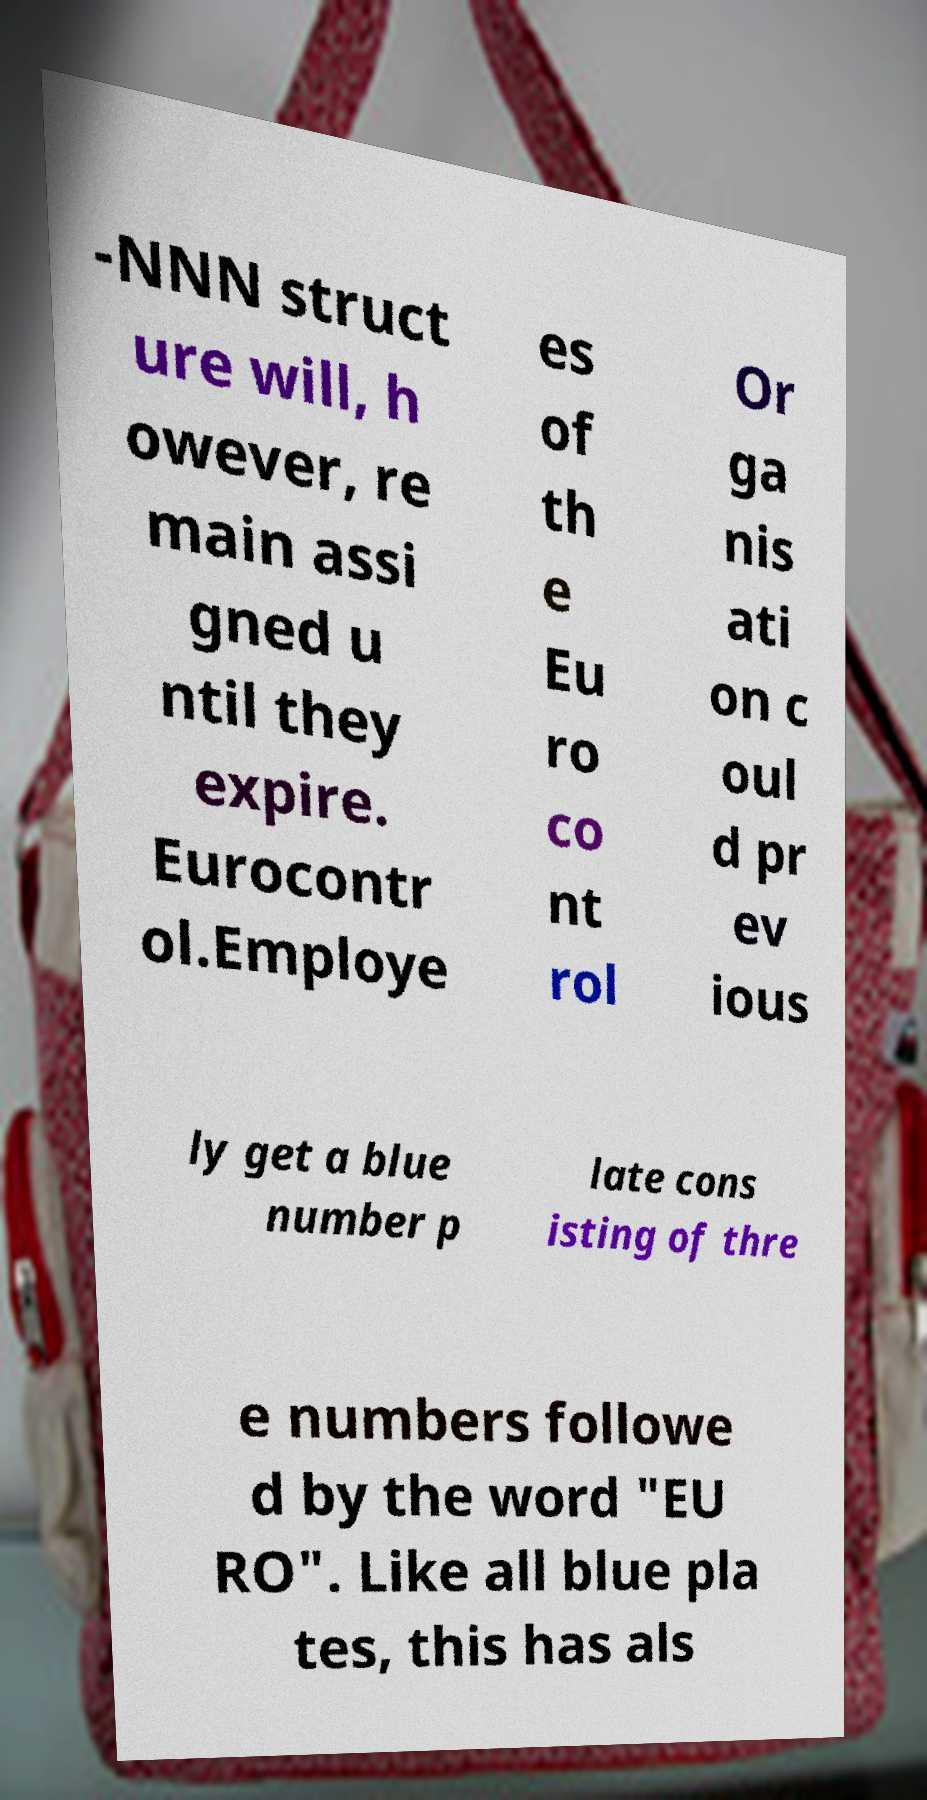Can you accurately transcribe the text from the provided image for me? -NNN struct ure will, h owever, re main assi gned u ntil they expire. Eurocontr ol.Employe es of th e Eu ro co nt rol Or ga nis ati on c oul d pr ev ious ly get a blue number p late cons isting of thre e numbers followe d by the word "EU RO". Like all blue pla tes, this has als 